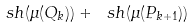<formula> <loc_0><loc_0><loc_500><loc_500>\ s h ( \mu ( Q _ { k } ) ) + \ s h ( \mu ( P _ { k + 1 } ) )</formula> 